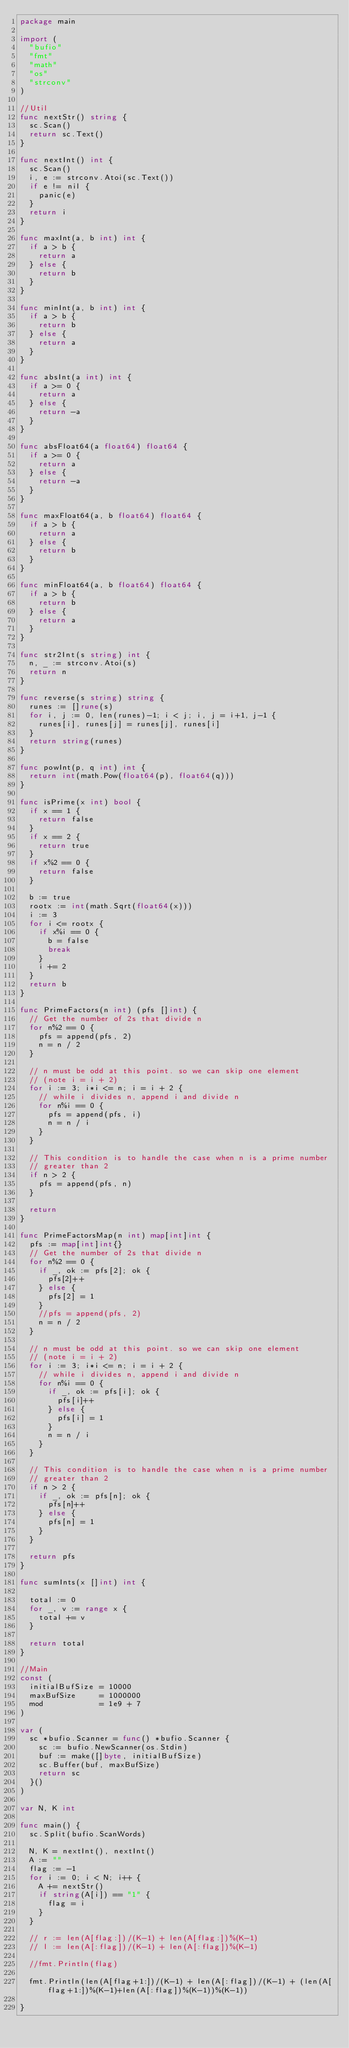<code> <loc_0><loc_0><loc_500><loc_500><_Go_>package main

import (
	"bufio"
	"fmt"
	"math"
	"os"
	"strconv"
)

//Util
func nextStr() string {
	sc.Scan()
	return sc.Text()
}

func nextInt() int {
	sc.Scan()
	i, e := strconv.Atoi(sc.Text())
	if e != nil {
		panic(e)
	}
	return i
}

func maxInt(a, b int) int {
	if a > b {
		return a
	} else {
		return b
	}
}

func minInt(a, b int) int {
	if a > b {
		return b
	} else {
		return a
	}
}

func absInt(a int) int {
	if a >= 0 {
		return a
	} else {
		return -a
	}
}

func absFloat64(a float64) float64 {
	if a >= 0 {
		return a
	} else {
		return -a
	}
}

func maxFloat64(a, b float64) float64 {
	if a > b {
		return a
	} else {
		return b
	}
}

func minFloat64(a, b float64) float64 {
	if a > b {
		return b
	} else {
		return a
	}
}

func str2Int(s string) int {
	n, _ := strconv.Atoi(s)
	return n
}

func reverse(s string) string {
	runes := []rune(s)
	for i, j := 0, len(runes)-1; i < j; i, j = i+1, j-1 {
		runes[i], runes[j] = runes[j], runes[i]
	}
	return string(runes)
}

func powInt(p, q int) int {
	return int(math.Pow(float64(p), float64(q)))
}

func isPrime(x int) bool {
	if x == 1 {
		return false
	}
	if x == 2 {
		return true
	}
	if x%2 == 0 {
		return false
	}

	b := true
	rootx := int(math.Sqrt(float64(x)))
	i := 3
	for i <= rootx {
		if x%i == 0 {
			b = false
			break
		}
		i += 2
	}
	return b
}

func PrimeFactors(n int) (pfs []int) {
	// Get the number of 2s that divide n
	for n%2 == 0 {
		pfs = append(pfs, 2)
		n = n / 2
	}

	// n must be odd at this point. so we can skip one element
	// (note i = i + 2)
	for i := 3; i*i <= n; i = i + 2 {
		// while i divides n, append i and divide n
		for n%i == 0 {
			pfs = append(pfs, i)
			n = n / i
		}
	}

	// This condition is to handle the case when n is a prime number
	// greater than 2
	if n > 2 {
		pfs = append(pfs, n)
	}

	return
}

func PrimeFactorsMap(n int) map[int]int {
	pfs := map[int]int{}
	// Get the number of 2s that divide n
	for n%2 == 0 {
		if _, ok := pfs[2]; ok {
			pfs[2]++
		} else {
			pfs[2] = 1
		}
		//pfs = append(pfs, 2)
		n = n / 2
	}

	// n must be odd at this point. so we can skip one element
	// (note i = i + 2)
	for i := 3; i*i <= n; i = i + 2 {
		// while i divides n, append i and divide n
		for n%i == 0 {
			if _, ok := pfs[i]; ok {
				pfs[i]++
			} else {
				pfs[i] = 1
			}
			n = n / i
		}
	}

	// This condition is to handle the case when n is a prime number
	// greater than 2
	if n > 2 {
		if _, ok := pfs[n]; ok {
			pfs[n]++
		} else {
			pfs[n] = 1
		}
	}

	return pfs
}

func sumInts(x []int) int {

	total := 0
	for _, v := range x {
		total += v
	}

	return total
}

//Main
const (
	initialBufSize = 10000
	maxBufSize     = 1000000
	mod            = 1e9 + 7
)

var (
	sc *bufio.Scanner = func() *bufio.Scanner {
		sc := bufio.NewScanner(os.Stdin)
		buf := make([]byte, initialBufSize)
		sc.Buffer(buf, maxBufSize)
		return sc
	}()
)

var N, K int

func main() {
	sc.Split(bufio.ScanWords)

	N, K = nextInt(), nextInt()
	A := ""
	flag := -1
	for i := 0; i < N; i++ {
		A += nextStr()
		if string(A[i]) == "1" {
			flag = i
		}
	}

	// r := len(A[flag:])/(K-1) + len(A[flag:])%(K-1)
	// l := len(A[:flag])/(K-1) + len(A[:flag])%(K-1)

	//fmt.Println(flag)

	fmt.Println(len(A[flag+1:])/(K-1) + len(A[:flag])/(K-1) + (len(A[flag+1:])%(K-1)+len(A[:flag])%(K-1))%(K-1))

}
</code> 